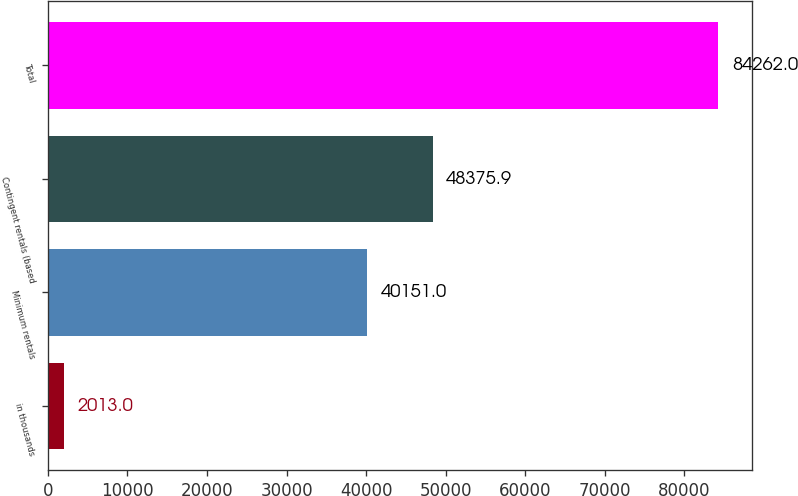Convert chart to OTSL. <chart><loc_0><loc_0><loc_500><loc_500><bar_chart><fcel>in thousands<fcel>Minimum rentals<fcel>Contingent rentals (based<fcel>Total<nl><fcel>2013<fcel>40151<fcel>48375.9<fcel>84262<nl></chart> 